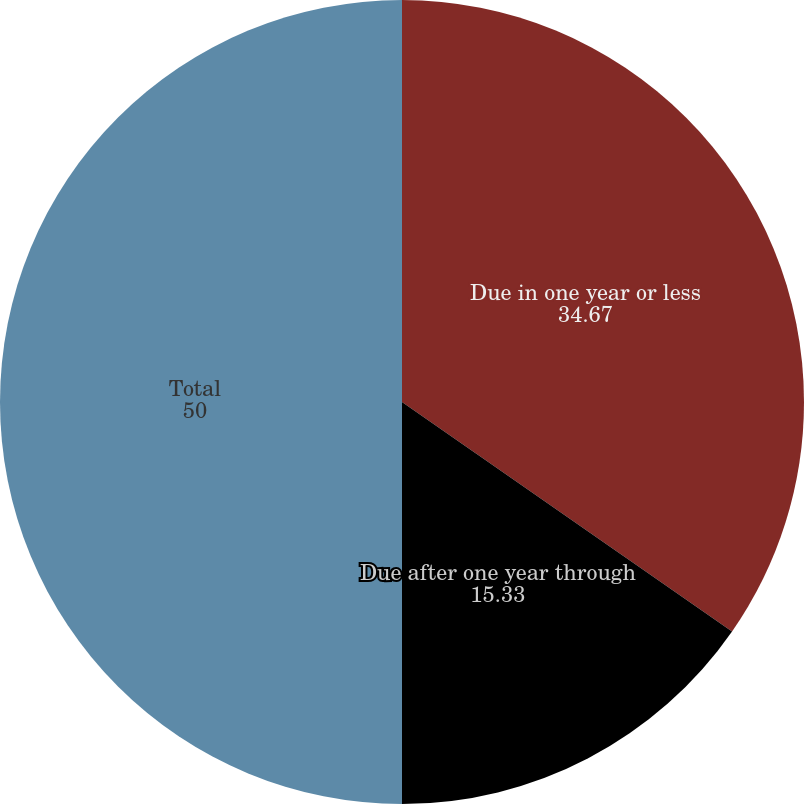Convert chart. <chart><loc_0><loc_0><loc_500><loc_500><pie_chart><fcel>Due in one year or less<fcel>Due after one year through<fcel>Total<nl><fcel>34.67%<fcel>15.33%<fcel>50.0%<nl></chart> 